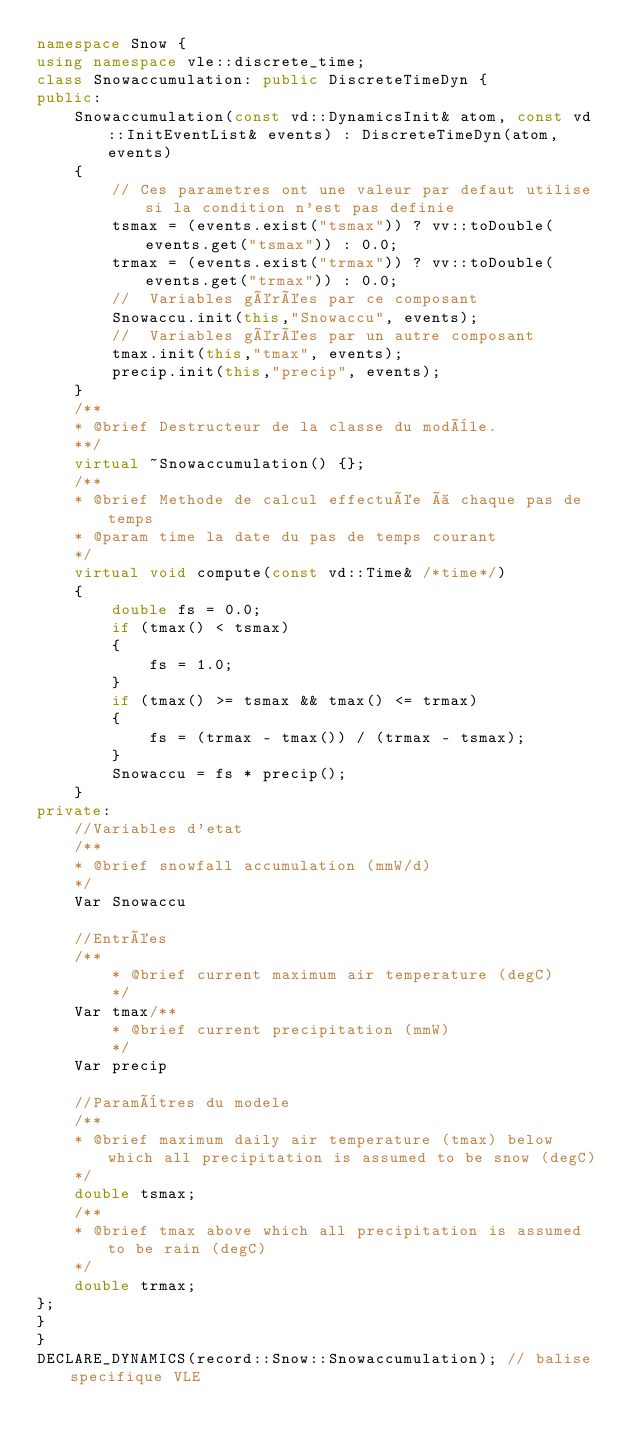Convert code to text. <code><loc_0><loc_0><loc_500><loc_500><_C++_>namespace Snow {
using namespace vle::discrete_time;
class Snowaccumulation: public DiscreteTimeDyn {
public:
    Snowaccumulation(const vd::DynamicsInit& atom, const vd::InitEventList& events) : DiscreteTimeDyn(atom, events)
    {
        // Ces parametres ont une valeur par defaut utilise si la condition n'est pas definie
        tsmax = (events.exist("tsmax")) ? vv::toDouble(events.get("tsmax")) : 0.0;
        trmax = (events.exist("trmax")) ? vv::toDouble(events.get("trmax")) : 0.0;
        //  Variables gérées par ce composant
        Snowaccu.init(this,"Snowaccu", events);
        //  Variables gérées par un autre composant
        tmax.init(this,"tmax", events);
        precip.init(this,"precip", events);
    }
    /**
    * @brief Destructeur de la classe du modèle.
    **/
    virtual ~Snowaccumulation() {};
    /**
    * @brief Methode de calcul effectuée à chaque pas de temps
    * @param time la date du pas de temps courant
    */
    virtual void compute(const vd::Time& /*time*/)
    {
        double fs = 0.0;
        if (tmax() < tsmax)
        {
            fs = 1.0;
        }
        if (tmax() >= tsmax && tmax() <= trmax)
        {
            fs = (trmax - tmax()) / (trmax - tsmax);
        }
        Snowaccu = fs * precip();
    }
private:
    //Variables d'etat
    /**
    * @brief snowfall accumulation (mmW/d)
    */
    Var Snowaccu

    //Entrées
    /**
        * @brief current maximum air temperature (degC)
        */
    Var tmax/**
        * @brief current precipitation (mmW)
        */
    Var precip

    //Paramètres du modele
    /**
    * @brief maximum daily air temperature (tmax) below which all precipitation is assumed to be snow (degC)
    */
    double tsmax;
    /**
    * @brief tmax above which all precipitation is assumed to be rain (degC)
    */
    double trmax;
};
}
}
DECLARE_DYNAMICS(record::Snow::Snowaccumulation); // balise specifique VLE</code> 